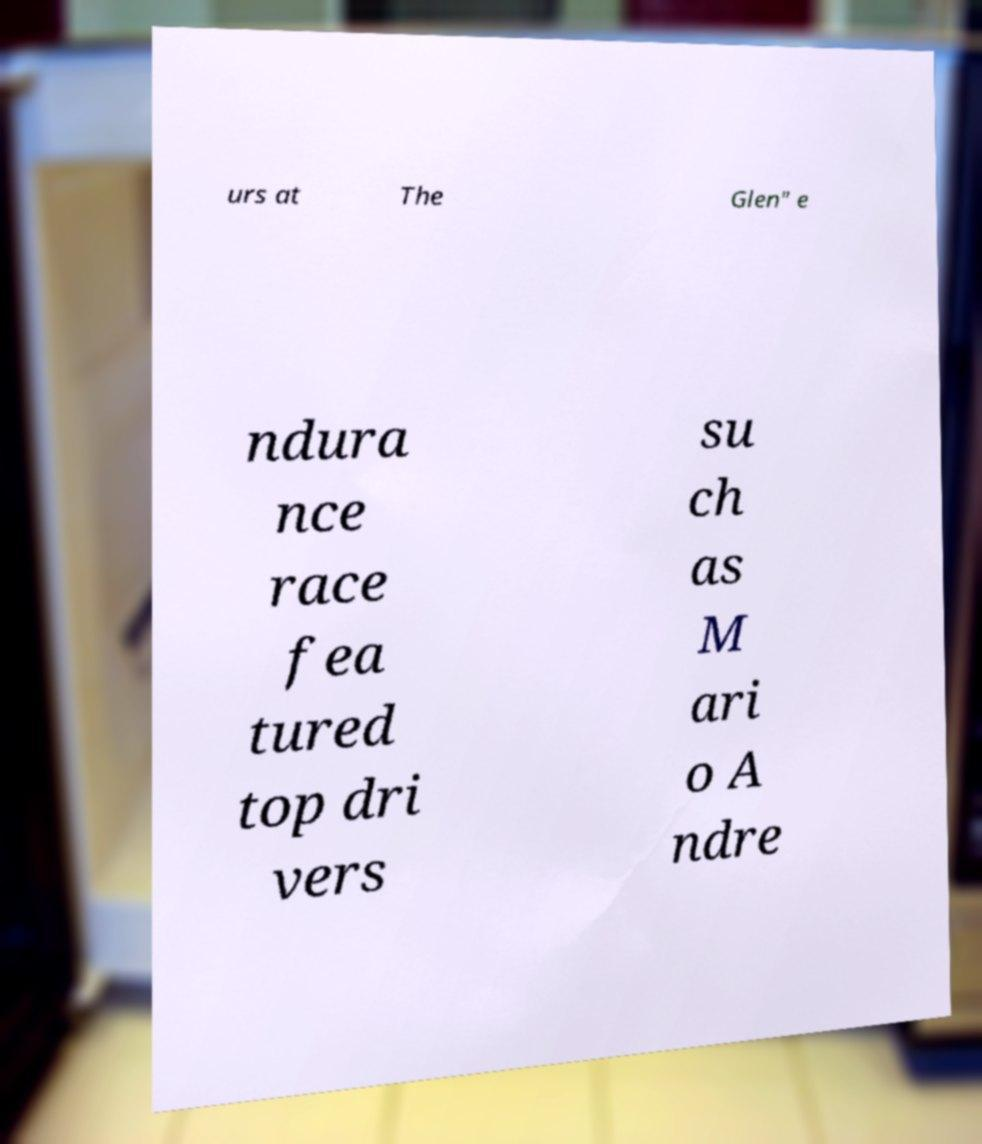What messages or text are displayed in this image? I need them in a readable, typed format. urs at The Glen" e ndura nce race fea tured top dri vers su ch as M ari o A ndre 